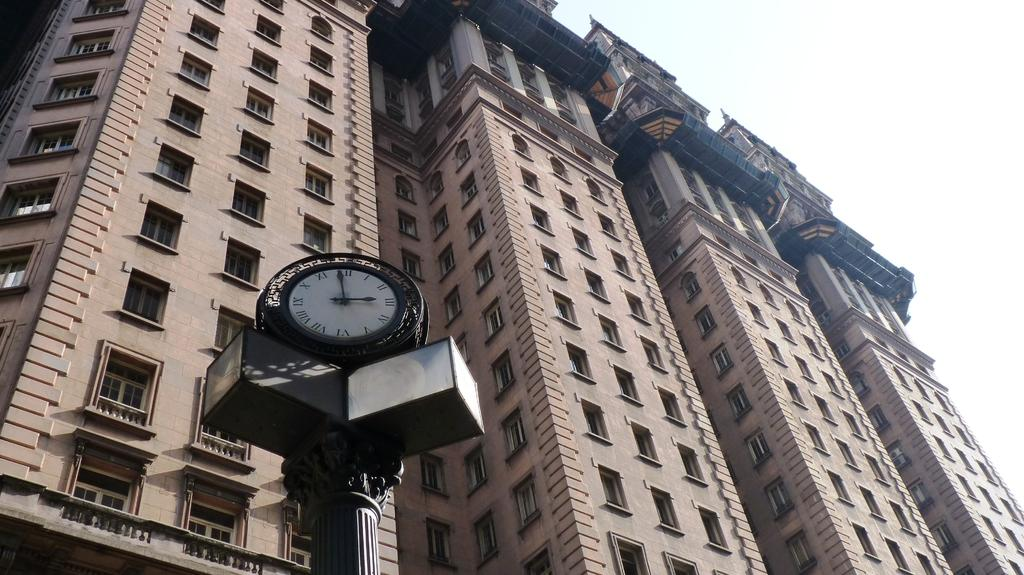<image>
Offer a succinct explanation of the picture presented. The time "3:00" is shown on the clock. 